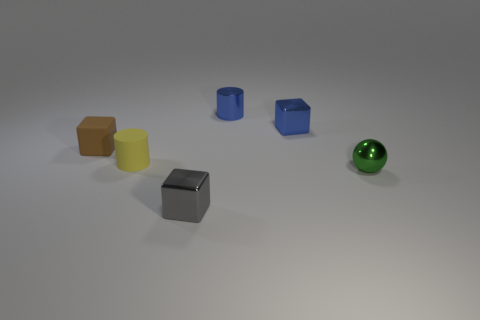Are there fewer metal balls left of the yellow cylinder than blue cylinders that are behind the small gray cube?
Make the answer very short. Yes. What number of gray blocks have the same material as the blue cube?
Your response must be concise. 1. Is there a tiny yellow rubber thing that is to the right of the blue thing left of the shiny cube that is behind the green metallic ball?
Make the answer very short. No. There is a small green object that is made of the same material as the gray object; what shape is it?
Your answer should be very brief. Sphere. Are there more small green objects than purple objects?
Your response must be concise. Yes. There is a small gray metallic thing; is its shape the same as the small rubber thing that is behind the yellow object?
Your answer should be compact. Yes. What is the material of the brown object?
Give a very brief answer. Rubber. What is the color of the tiny cylinder behind the metal cube that is right of the tiny shiny cube that is in front of the small yellow cylinder?
Your answer should be very brief. Blue. What is the material of the gray object that is the same shape as the brown thing?
Make the answer very short. Metal. How many brown things have the same size as the green ball?
Offer a terse response. 1. 